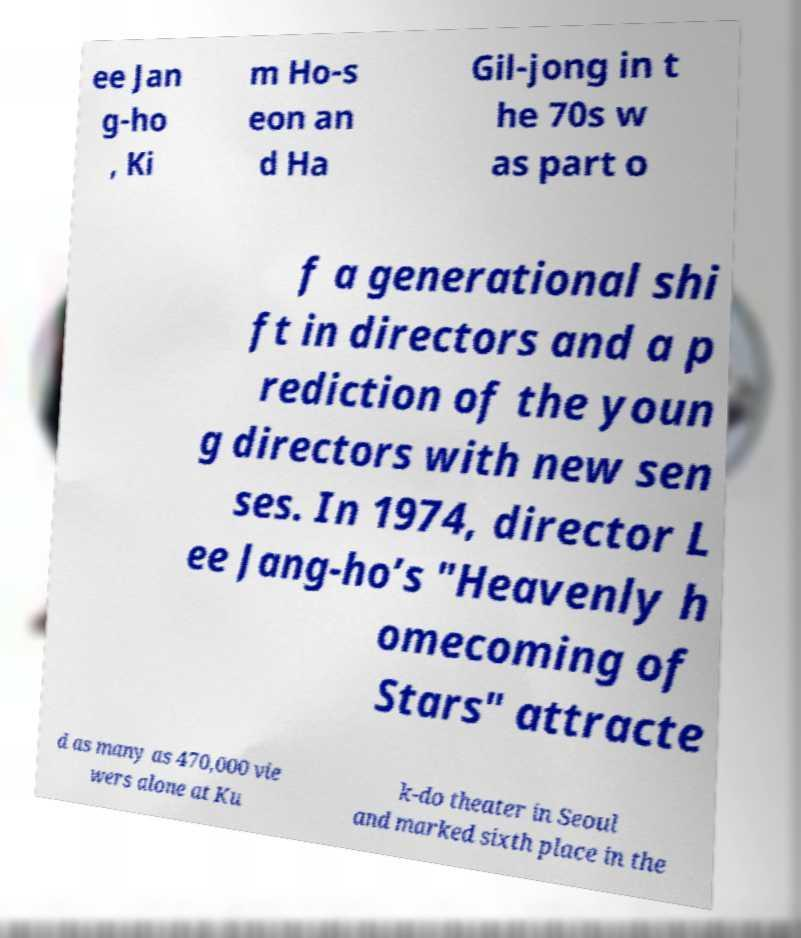Please read and relay the text visible in this image. What does it say? ee Jan g-ho , Ki m Ho-s eon an d Ha Gil-jong in t he 70s w as part o f a generational shi ft in directors and a p rediction of the youn g directors with new sen ses. In 1974, director L ee Jang-ho’s "Heavenly h omecoming of Stars" attracte d as many as 470,000 vie wers alone at Ku k-do theater in Seoul and marked sixth place in the 